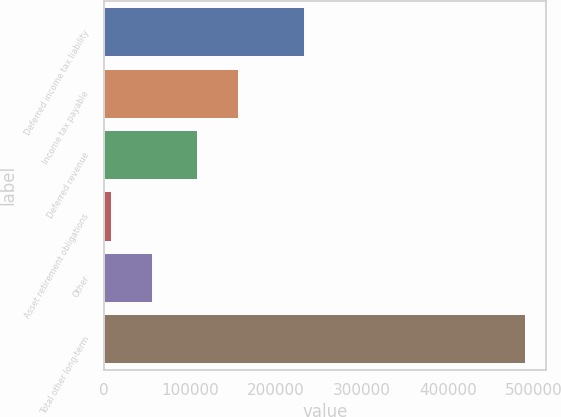Convert chart. <chart><loc_0><loc_0><loc_500><loc_500><bar_chart><fcel>Deferred income tax liability<fcel>Income tax payable<fcel>Deferred revenue<fcel>Asset retirement obligations<fcel>Other<fcel>Total other long-term<nl><fcel>232307<fcel>155988<fcel>107838<fcel>7428<fcel>55578<fcel>488928<nl></chart> 